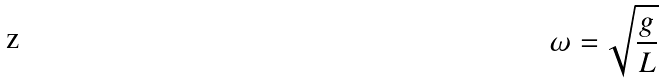<formula> <loc_0><loc_0><loc_500><loc_500>\omega = { \sqrt { \frac { g } { L } } }</formula> 